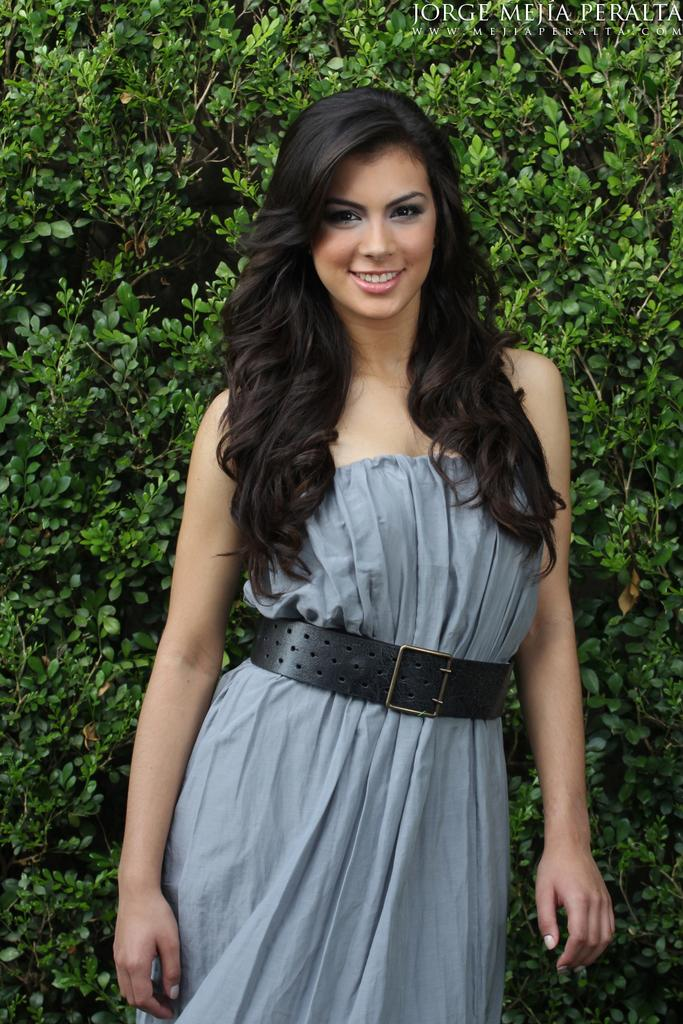Who is the main subject in the image? There is a girl in the center of the image. What can be seen in the background of the image? There are plants in the background of the image. What type of cheese is the girl holding in the image? There is no cheese present in the image; the girl is not holding any cheese. 